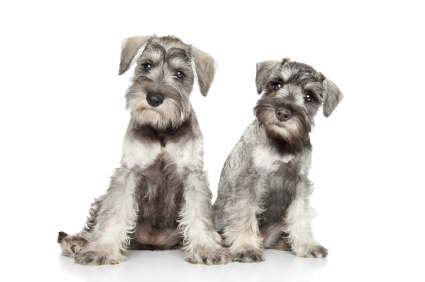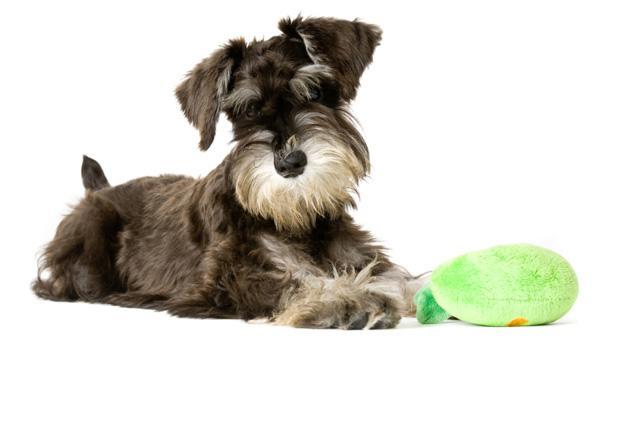The first image is the image on the left, the second image is the image on the right. Examine the images to the left and right. Is the description "There are two dogs in one of the images." accurate? Answer yes or no. Yes. 